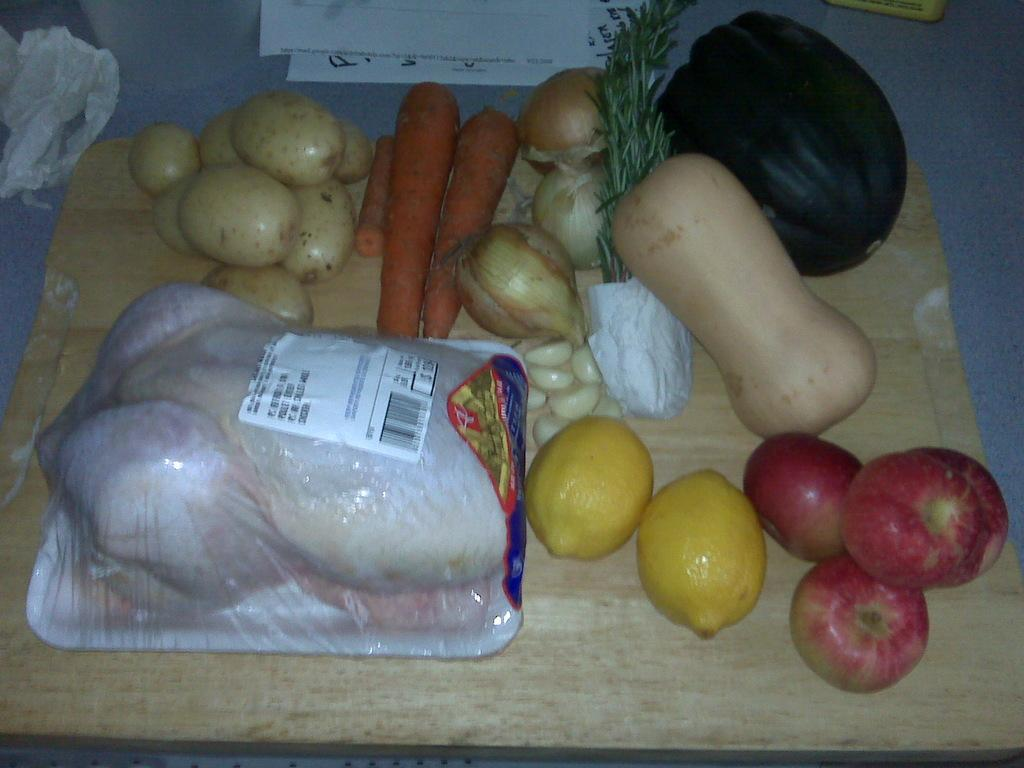What types of food items are present in the image? There is a group of vegetables, a group of fruits, and meat in the image. How are the vegetables and fruits arranged in the image? The vegetables and fruits are placed on a tray in the image. Where are the vegetables, fruits, and meat located in the image? They are placed on a table in the image. What type of debt is being discussed in the image? There is no mention of debt in the image; it features a group of vegetables, fruits, and meat on a table. What caption is written on the image? There is no caption present in the image; it is a photograph of food items on a table. 